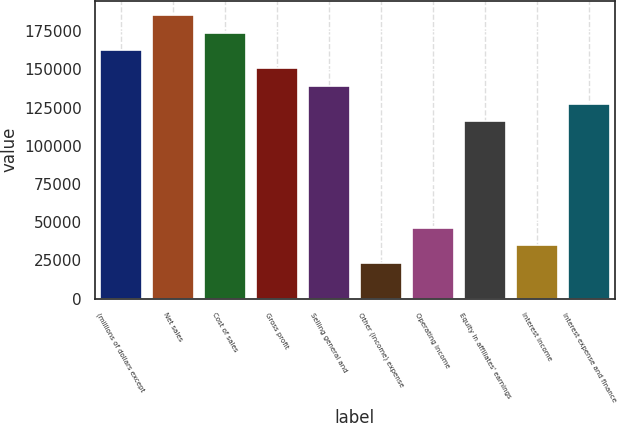<chart> <loc_0><loc_0><loc_500><loc_500><bar_chart><fcel>(millions of dollars except<fcel>Net sales<fcel>Cost of sales<fcel>Gross profit<fcel>Selling general and<fcel>Other (income) expense<fcel>Operating income<fcel>Equity in affiliates' earnings<fcel>Interest income<fcel>Interest expense and finance<nl><fcel>162410<fcel>185611<fcel>174010<fcel>150809<fcel>139208<fcel>23201.7<fcel>46403<fcel>116007<fcel>34802.3<fcel>127608<nl></chart> 